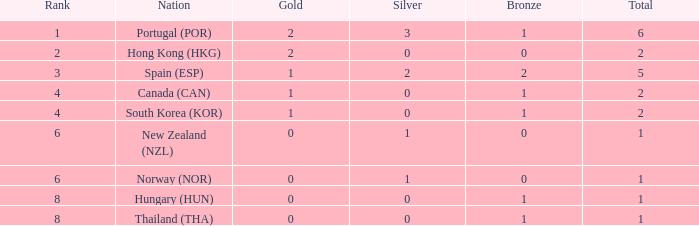What is the least total value with 0 bronze and a rank under 2? None. 